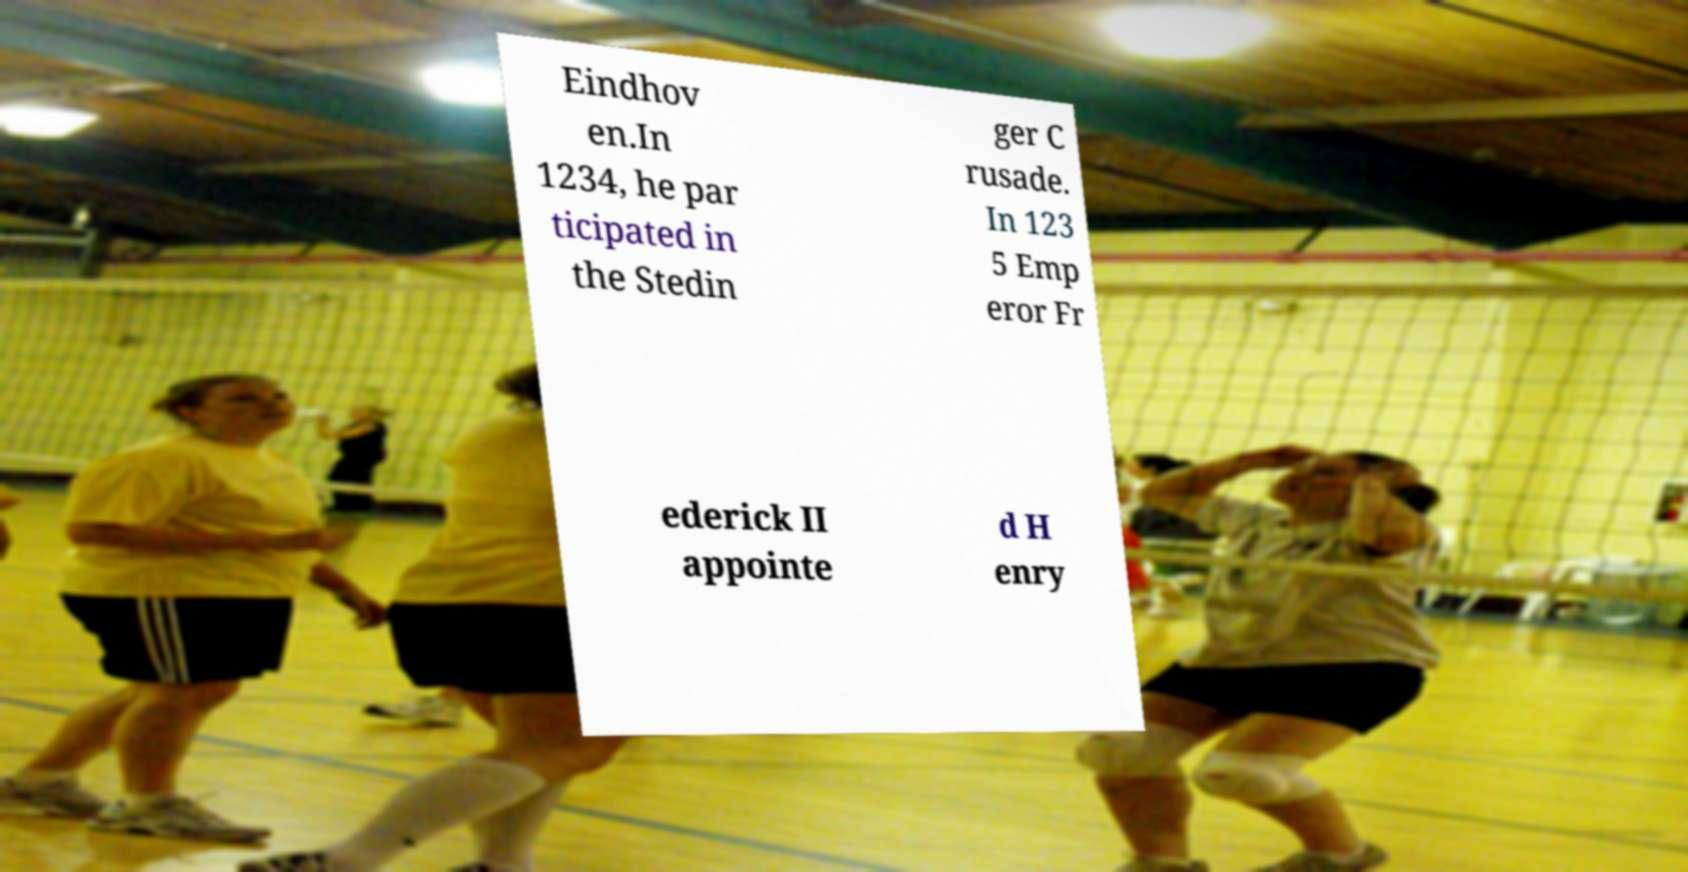Could you extract and type out the text from this image? Eindhov en.In 1234, he par ticipated in the Stedin ger C rusade. In 123 5 Emp eror Fr ederick II appointe d H enry 